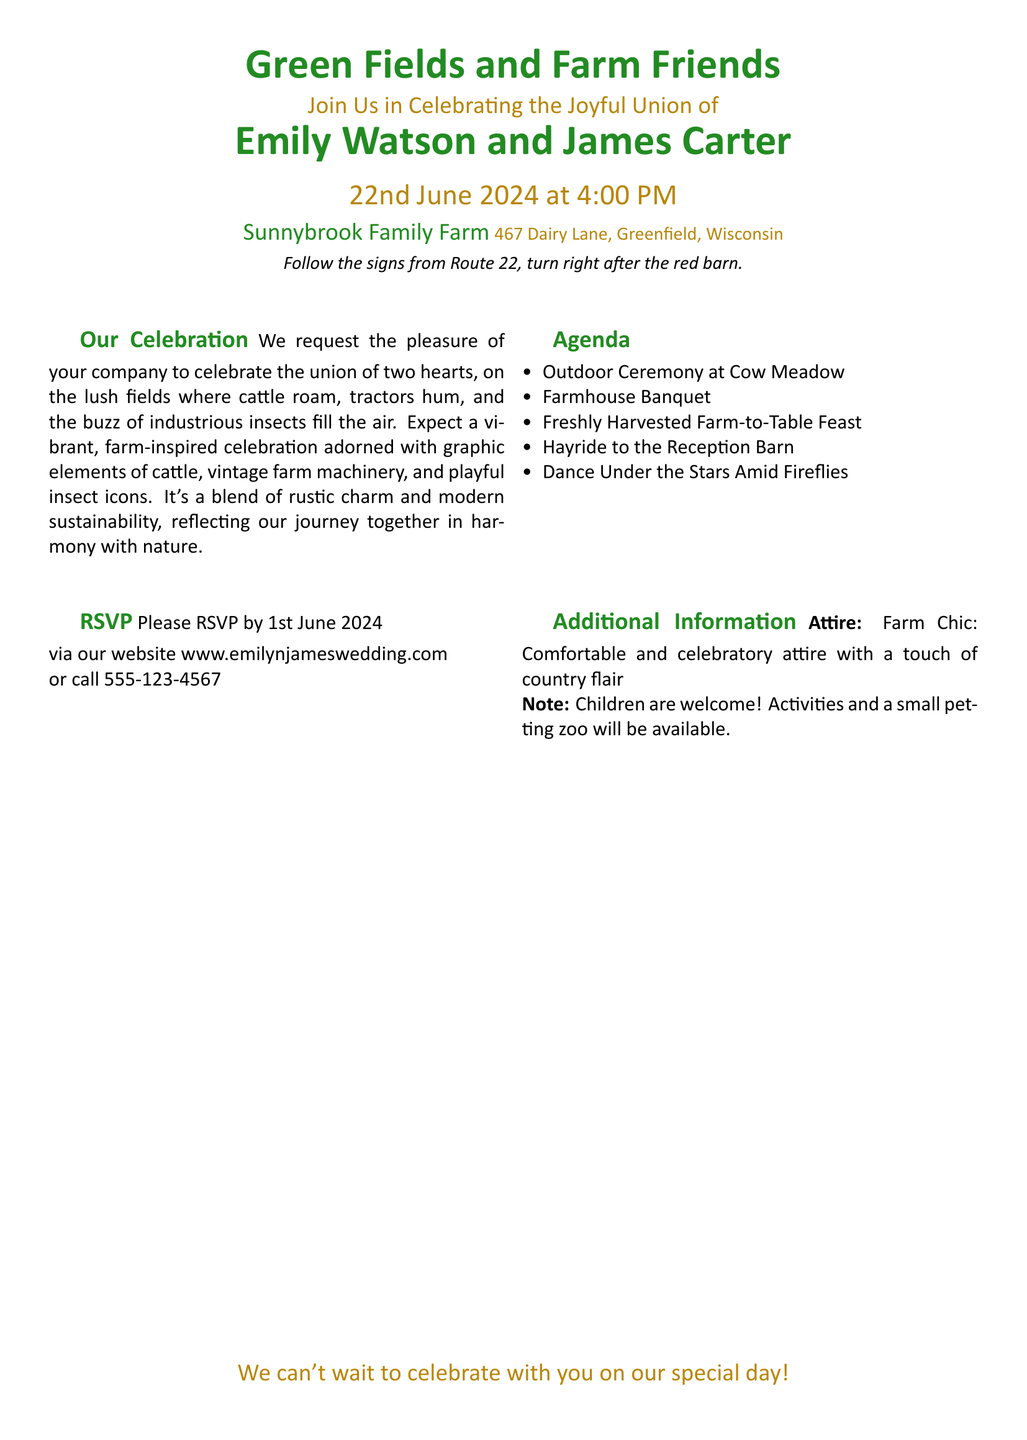What is the title of the wedding invitation? The title is prominently displayed in a larger font at the top of the invitation, which reads "Green Fields and Farm Friends."
Answer: Green Fields and Farm Friends Who are the couple getting married? The names of the couple getting married are highlighted in a larger, bold font within the invitation.
Answer: Emily Watson and James Carter What is the date of the wedding? The date is stated clearly in a larger font within the invitation, emphasizing the importance of this detail.
Answer: 22nd June 2024 What time does the wedding ceremony start? The start time of the ceremony is included in a larger font and is easy to locate on the invitation.
Answer: 4:00 PM What is the location of the wedding? The wedding venue is detailed along with the address, making it easy for guests to find.
Answer: Sunnybrook Family Farm, 467 Dairy Lane, Greenfield, Wisconsin What is the dress code for the event? The attire is mentioned under additional information, specifying what guests should wear for the celebration.
Answer: Farm Chic What activities are planned for the guests? The agenda lists various enjoyable activities that will take place during the celebration, showing the festive nature of the event.
Answer: Outdoor Ceremony, Farmhouse Banquet, Freshly Harvested Farm-to-Table Feast, Hayride, Dance Under the Stars When is the RSVP deadline? The RSVP deadline is clearly stated, helping guests know when they need to respond.
Answer: 1st June 2024 Is there any provision for children at the event? The invitation mentions whether children are welcomed, indicating the family-friendly nature of the celebration.
Answer: Yes, activities and a small petting zoo will be available 